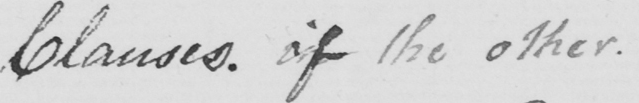Can you read and transcribe this handwriting? Clauses . of the other . 